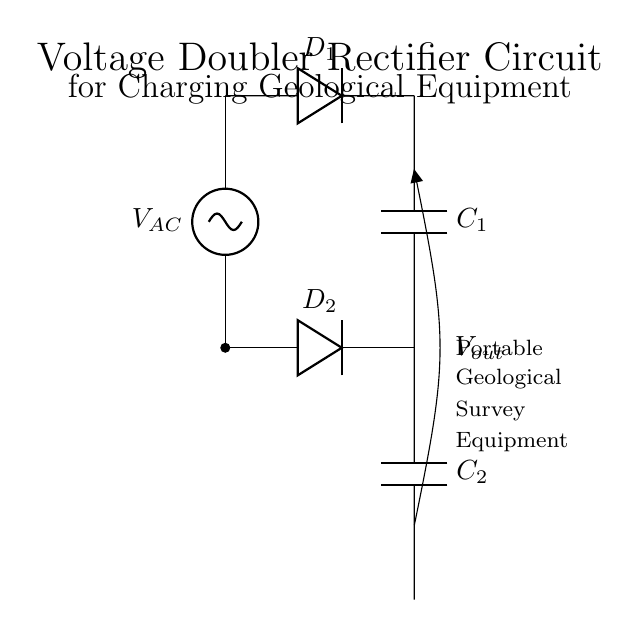What are the main components of this circuit? The circuit consists of an AC source, two diodes (D1 and D2), and two capacitors (C1 and C2). These components help in the rectifying and voltage-doubling process.
Answer: AC source, D1, D2, C1, C2 What type of rectification does this circuit perform? This circuit performs full-wave rectification because it uses two diodes to convert both halves of the AC waveform into a unidirectional output voltage.
Answer: Full-wave What is the purpose of the capacitors in this circuit? The capacitors store energy during the rectification process and smooth the output voltage, providing a more stable charge for the connected device.
Answer: Energy storage How does the voltage output relate to the input voltage? The voltage output is approximately double the input voltage due to the configuration and operation of the voltage doubler circuit made with capacitors and diodes.
Answer: Double What happens to the output voltage when the load is connected? When a load is connected, the output voltage may drop slightly due to the internal resistance of the circuit and the capacitors discharging under load, especially if the load demand is high.
Answer: Voltage drop What role do the diodes play in the circuit? The diodes allow current to flow in only one direction, preventing backflow and helping in the conversion of AC voltage to pulsating DC, which is essential in rectification.
Answer: Unidirectional current flow What is the output voltage notation in this circuit? The output voltage is labeled as Vout, indicating the voltage available for charging the portable geological survey equipment, which is critical for its operation.
Answer: Vout 